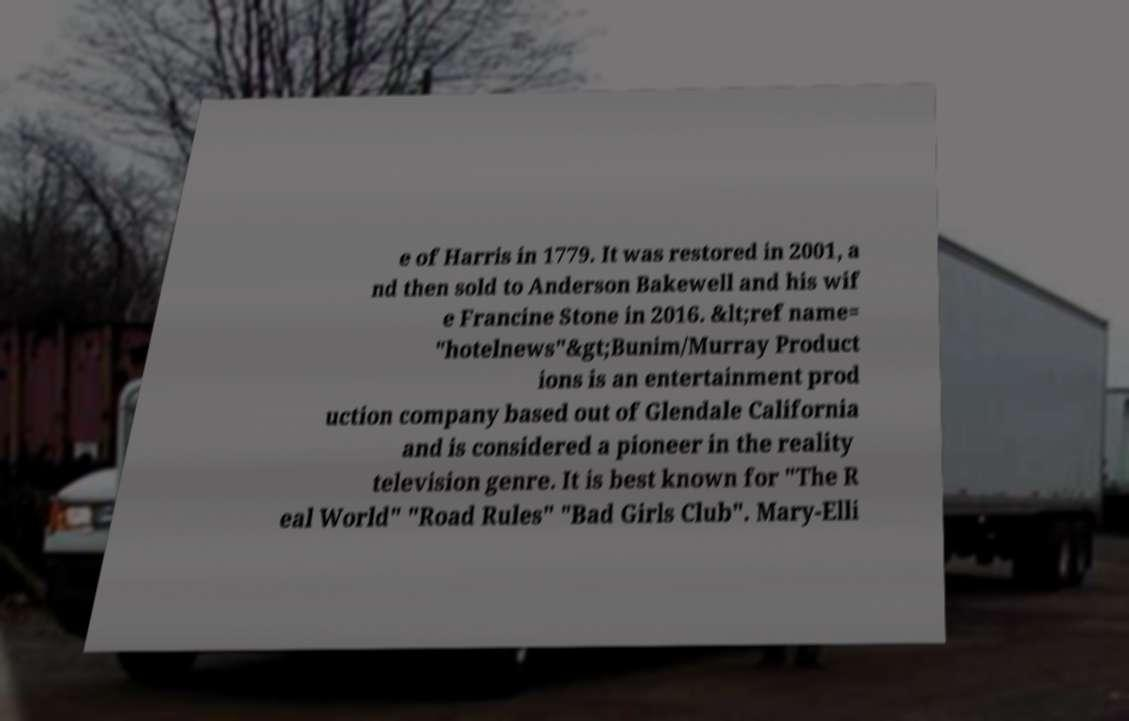For documentation purposes, I need the text within this image transcribed. Could you provide that? e of Harris in 1779. It was restored in 2001, a nd then sold to Anderson Bakewell and his wif e Francine Stone in 2016. &lt;ref name= "hotelnews"&gt;Bunim/Murray Product ions is an entertainment prod uction company based out of Glendale California and is considered a pioneer in the reality television genre. It is best known for "The R eal World" "Road Rules" "Bad Girls Club". Mary-Elli 